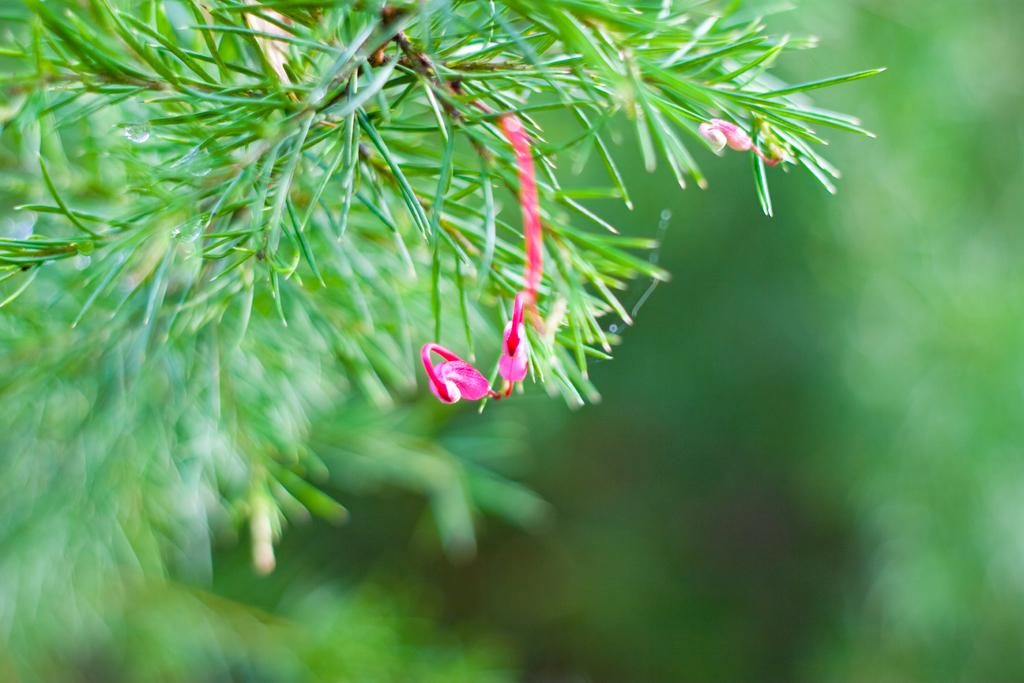What type of vegetation is present in the image? There is a tree or a plant in the image. What specific feature can be observed on the tree or plant? The tree or plant has flowers. What color are the flowers? The flowers are pink in color. What can be seen in the background of the image? The background of the image is green and blurred. What route does the rake take to reach the muscle in the image? There is no rake or muscle present in the image; it features a tree or plant with pink flowers and a green, blurred background. 